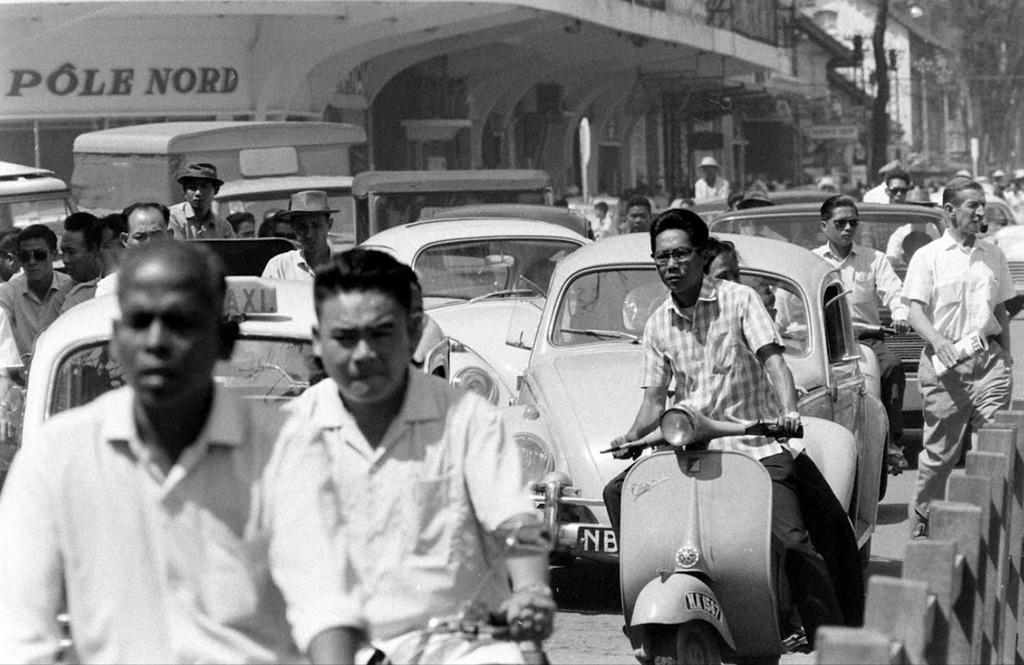What is the color scheme of the image? The image is black and white. What type of vehicles can be seen in the image? There are many cars in the image. What are the people in the image doing? There are people walking and riding scooters in the image. Where does the scene take place? The scene takes place on a road. What can be seen in the background of the image? There is a bridge in the background of the image. What time of day is it in the image, and what is the wall made of? The image does not provide information about the time of day, and there is no wall present in the image. 